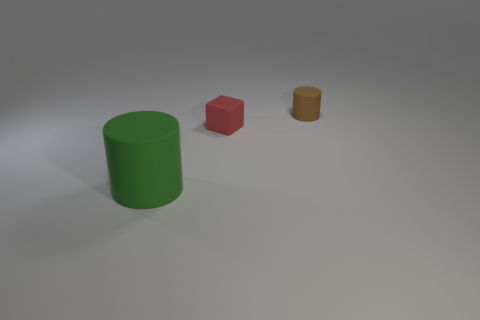What shape is the object that is the same size as the cube?
Your answer should be very brief. Cylinder. Is there another tiny brown thing that has the same shape as the brown object?
Provide a short and direct response. No. What shape is the large green rubber thing in front of the matte cylinder that is behind the green rubber cylinder?
Provide a short and direct response. Cylinder. The green thing has what shape?
Your response must be concise. Cylinder. How many other things are made of the same material as the red thing?
Ensure brevity in your answer.  2. How many rubber things are in front of the small matte thing that is to the right of the tiny red rubber block?
Offer a very short reply. 2. How many spheres are large green objects or small objects?
Your answer should be compact. 0. The thing that is to the left of the small brown matte object and to the right of the big green matte cylinder is what color?
Ensure brevity in your answer.  Red. The cylinder that is right of the cube in front of the tiny brown matte cylinder is what color?
Your answer should be very brief. Brown. Do the cube and the brown thing have the same size?
Keep it short and to the point. Yes. 